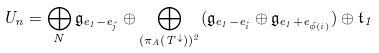Convert formula to latex. <formula><loc_0><loc_0><loc_500><loc_500>U _ { n } = \bigoplus _ { N } \mathfrak { g } _ { e _ { 1 } - e _ { \tilde { j } } } \oplus \bigoplus _ { ( \pi _ { A } ( T ^ { \downarrow } ) ) ^ { 2 } } ( \mathfrak { g } _ { e _ { 1 } - e _ { \tilde { i } } } \oplus \mathfrak { g } _ { e _ { 1 } + e _ { \tilde { \phi } ( i ) } } ) \oplus \mathfrak { t } _ { 1 }</formula> 